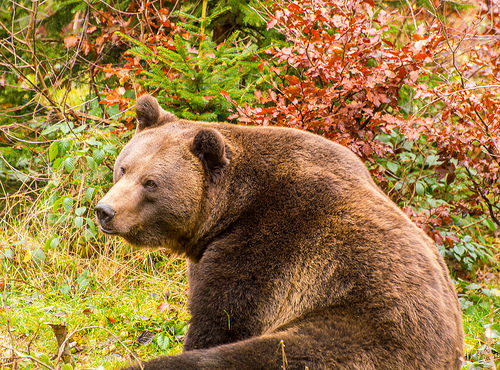<image>
Can you confirm if the brush is behind the grizzly bear? Yes. From this viewpoint, the brush is positioned behind the grizzly bear, with the grizzly bear partially or fully occluding the brush. Is the bear on the grass? Yes. Looking at the image, I can see the bear is positioned on top of the grass, with the grass providing support. 